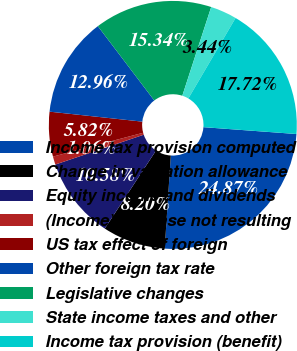Convert chart to OTSL. <chart><loc_0><loc_0><loc_500><loc_500><pie_chart><fcel>Income tax provision computed<fcel>Change in valuation allowance<fcel>Equity income and dividends<fcel>(Income) expense not resulting<fcel>US tax effect of foreign<fcel>Other foreign tax rate<fcel>Legislative changes<fcel>State income taxes and other<fcel>Income tax provision (benefit)<nl><fcel>24.87%<fcel>8.2%<fcel>10.58%<fcel>1.06%<fcel>5.82%<fcel>12.96%<fcel>15.34%<fcel>3.44%<fcel>17.72%<nl></chart> 